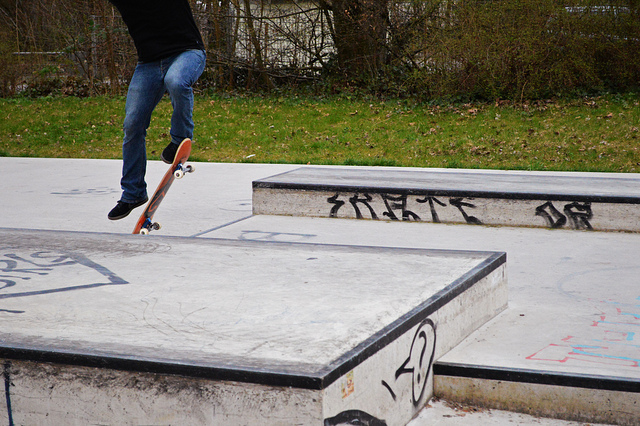Please transcribe the text in this image. DR 